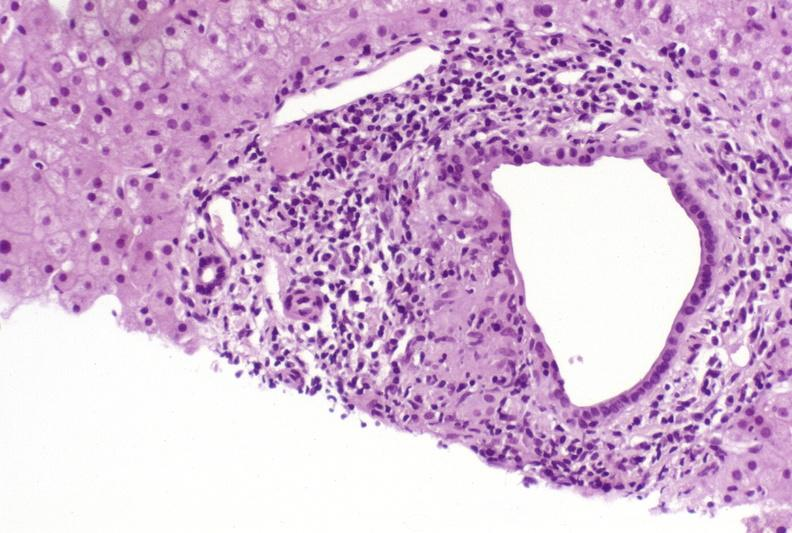what does this image show?
Answer the question using a single word or phrase. Primary biliary cirrhosis 